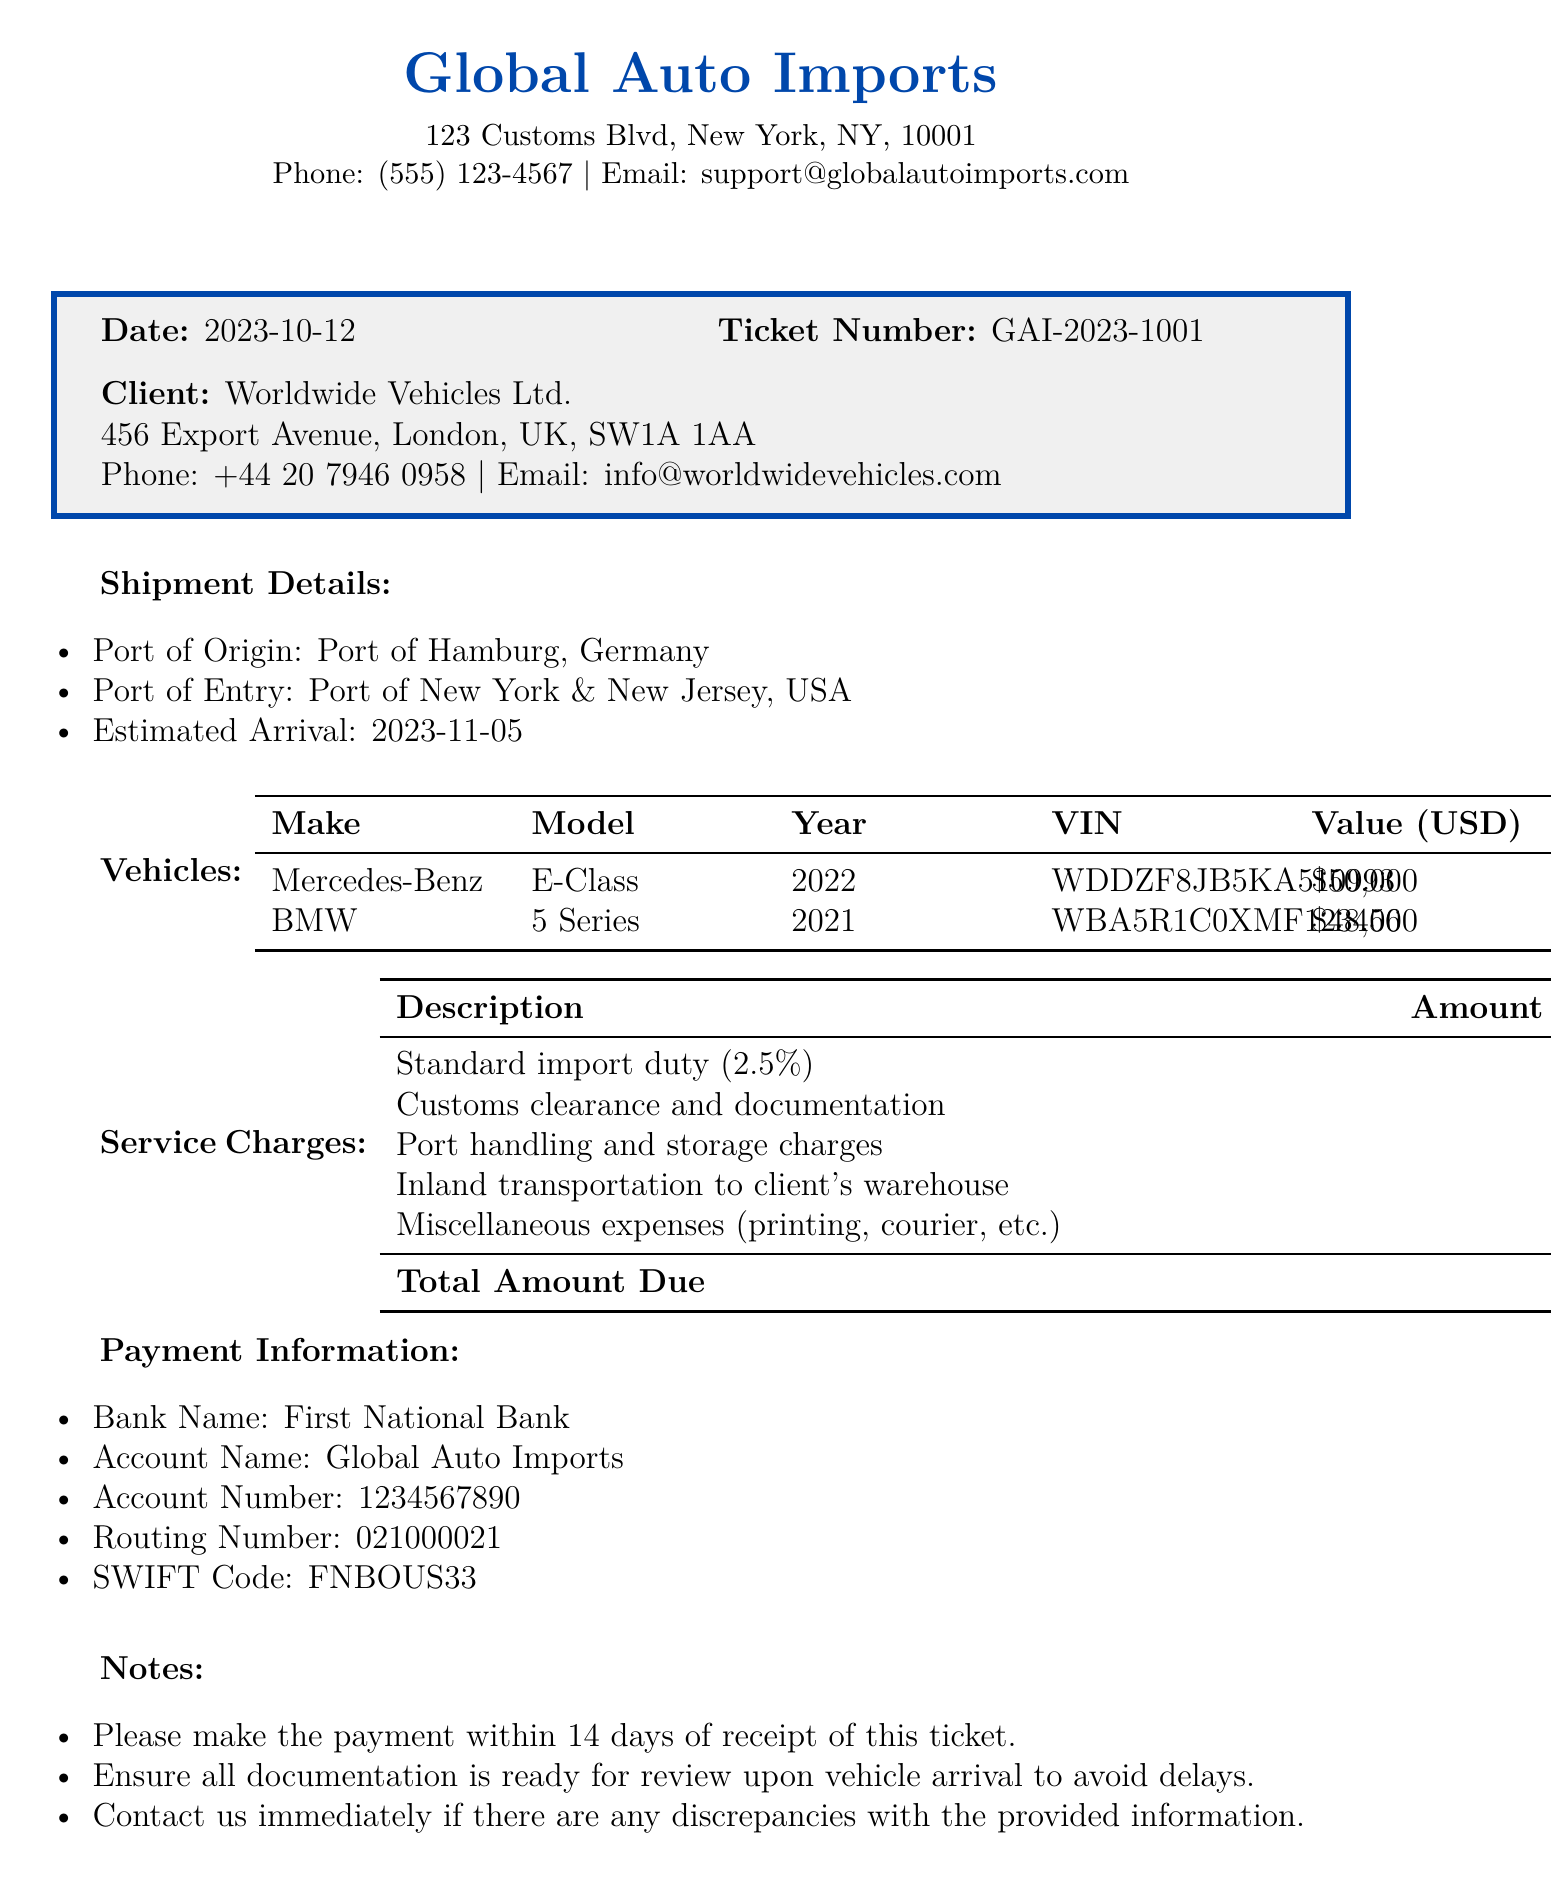What is the date of the ticket? The date of the ticket is stated at the top of the document.
Answer: 2023-10-12 What is the total amount due? The total amount due is summarized in the service charges section.
Answer: $4,900 What is the VIN of the BMW? The VIN of the BMW can be found in the vehicles table.
Answer: WBA5R1C0XMF123456 What is the estimated arrival date of the shipment? The estimated arrival date is listed in the shipment details section.
Answer: 2023-11-05 How much are the customs clearance and documentation charges? This amount is explicitly listed in the service charges table.
Answer: $800 Which bank should the payment be made to? The bank name is provided in the payment information section.
Answer: First National Bank What percentage is the standard import duty? The percentage of the standard import duty is indicated in the service charges.
Answer: 2.5% What miscellaneous expenses are included? Miscellaneous expenses are detailed in the service charges table.
Answer: $150 How many vehicles are listed in the document? The number of vehicles can be counted in the vehicles section.
Answer: 2 